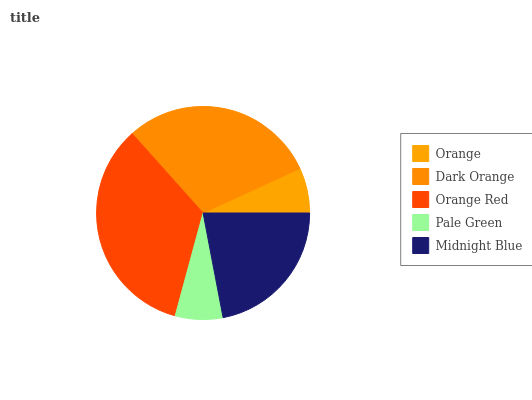Is Orange the minimum?
Answer yes or no. Yes. Is Orange Red the maximum?
Answer yes or no. Yes. Is Dark Orange the minimum?
Answer yes or no. No. Is Dark Orange the maximum?
Answer yes or no. No. Is Dark Orange greater than Orange?
Answer yes or no. Yes. Is Orange less than Dark Orange?
Answer yes or no. Yes. Is Orange greater than Dark Orange?
Answer yes or no. No. Is Dark Orange less than Orange?
Answer yes or no. No. Is Midnight Blue the high median?
Answer yes or no. Yes. Is Midnight Blue the low median?
Answer yes or no. Yes. Is Orange the high median?
Answer yes or no. No. Is Orange Red the low median?
Answer yes or no. No. 